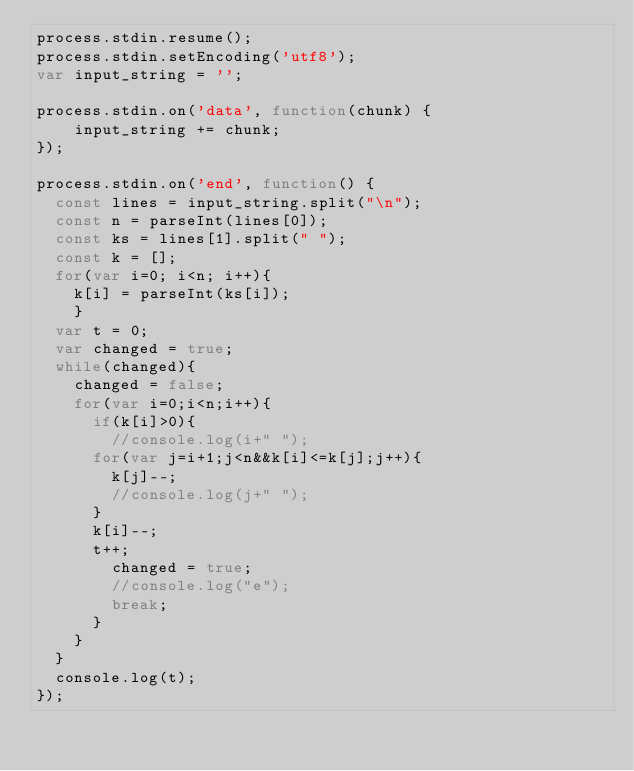Convert code to text. <code><loc_0><loc_0><loc_500><loc_500><_JavaScript_>process.stdin.resume();
process.stdin.setEncoding('utf8');
var input_string = '';

process.stdin.on('data', function(chunk) {
    input_string += chunk;
});

process.stdin.on('end', function() {
  const lines = input_string.split("\n");
  const n = parseInt(lines[0]);
  const ks = lines[1].split(" ");
  const k = [];
  for(var i=0; i<n; i++){
    k[i] = parseInt(ks[i]);
    }
  var t = 0;
  var changed = true;
  while(changed){
    changed = false;
    for(var i=0;i<n;i++){
      if(k[i]>0){
        //console.log(i+" ");
      for(var j=i+1;j<n&&k[i]<=k[j];j++){
        k[j]--;
        //console.log(j+" ");
      }
      k[i]--;
      t++;
        changed = true;
        //console.log("e");
        break;
      }
    }
  }
  console.log(t);
});</code> 